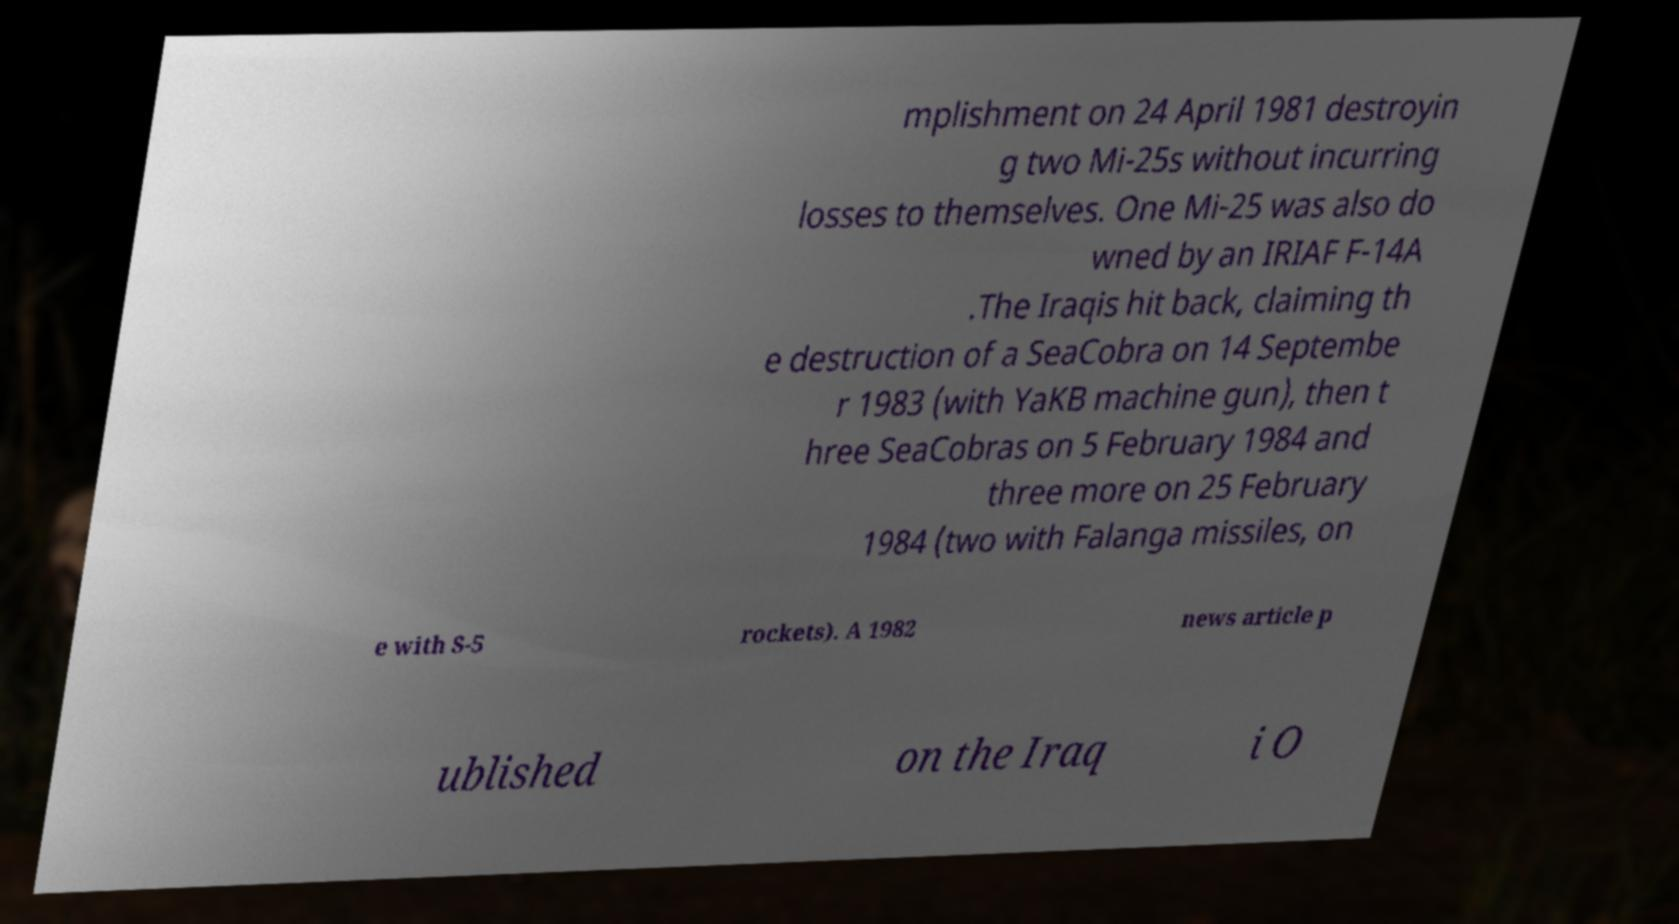Please read and relay the text visible in this image. What does it say? mplishment on 24 April 1981 destroyin g two Mi-25s without incurring losses to themselves. One Mi-25 was also do wned by an IRIAF F-14A .The Iraqis hit back, claiming th e destruction of a SeaCobra on 14 Septembe r 1983 (with YaKB machine gun), then t hree SeaCobras on 5 February 1984 and three more on 25 February 1984 (two with Falanga missiles, on e with S-5 rockets). A 1982 news article p ublished on the Iraq i O 